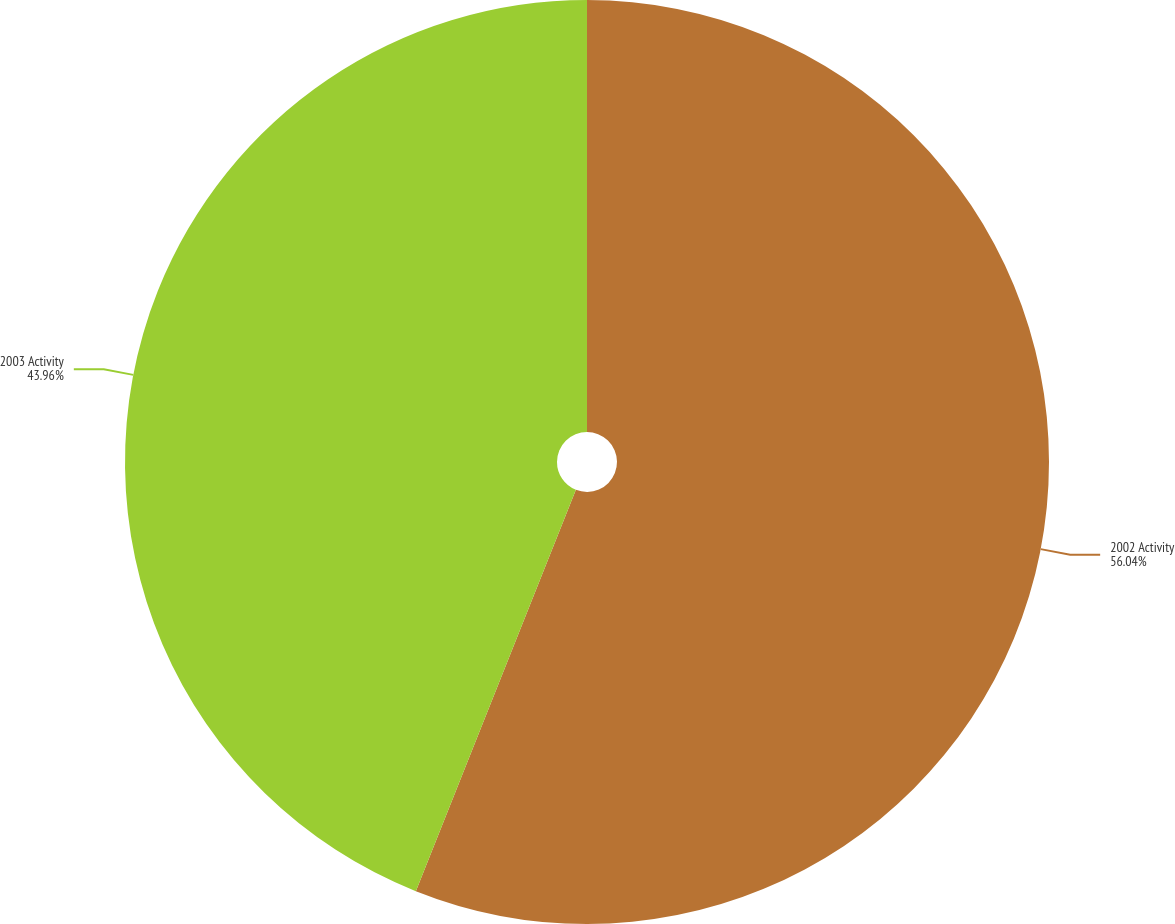<chart> <loc_0><loc_0><loc_500><loc_500><pie_chart><fcel>2002 Activity<fcel>2003 Activity<nl><fcel>56.04%<fcel>43.96%<nl></chart> 